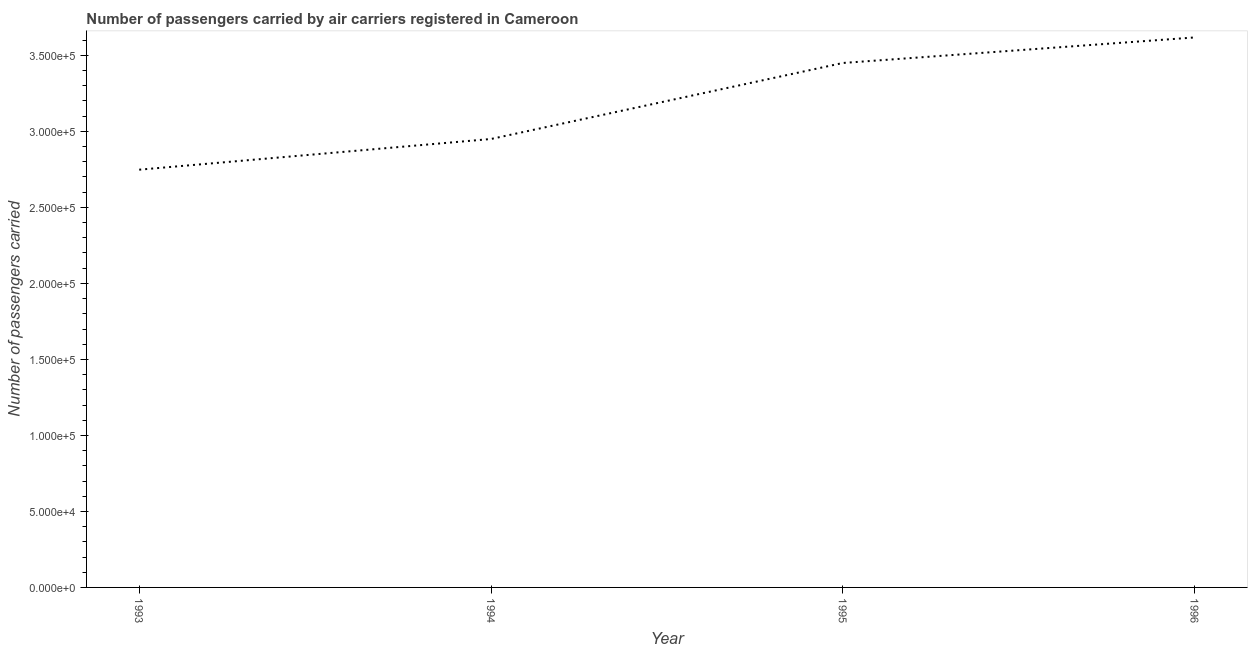What is the number of passengers carried in 1996?
Keep it short and to the point. 3.62e+05. Across all years, what is the maximum number of passengers carried?
Keep it short and to the point. 3.62e+05. Across all years, what is the minimum number of passengers carried?
Provide a succinct answer. 2.75e+05. In which year was the number of passengers carried minimum?
Your answer should be compact. 1993. What is the sum of the number of passengers carried?
Your answer should be compact. 1.28e+06. What is the difference between the number of passengers carried in 1993 and 1996?
Ensure brevity in your answer.  -8.70e+04. What is the average number of passengers carried per year?
Make the answer very short. 3.19e+05. In how many years, is the number of passengers carried greater than 250000 ?
Offer a terse response. 4. What is the ratio of the number of passengers carried in 1993 to that in 1996?
Your response must be concise. 0.76. Is the number of passengers carried in 1995 less than that in 1996?
Provide a short and direct response. Yes. What is the difference between the highest and the second highest number of passengers carried?
Provide a short and direct response. 1.68e+04. Is the sum of the number of passengers carried in 1993 and 1994 greater than the maximum number of passengers carried across all years?
Offer a very short reply. Yes. What is the difference between the highest and the lowest number of passengers carried?
Provide a succinct answer. 8.70e+04. In how many years, is the number of passengers carried greater than the average number of passengers carried taken over all years?
Give a very brief answer. 2. Does the number of passengers carried monotonically increase over the years?
Your answer should be very brief. Yes. What is the difference between two consecutive major ticks on the Y-axis?
Your answer should be very brief. 5.00e+04. Are the values on the major ticks of Y-axis written in scientific E-notation?
Provide a succinct answer. Yes. Does the graph contain any zero values?
Make the answer very short. No. What is the title of the graph?
Make the answer very short. Number of passengers carried by air carriers registered in Cameroon. What is the label or title of the X-axis?
Ensure brevity in your answer.  Year. What is the label or title of the Y-axis?
Make the answer very short. Number of passengers carried. What is the Number of passengers carried of 1993?
Provide a short and direct response. 2.75e+05. What is the Number of passengers carried of 1994?
Your answer should be very brief. 2.95e+05. What is the Number of passengers carried of 1995?
Your response must be concise. 3.45e+05. What is the Number of passengers carried in 1996?
Provide a short and direct response. 3.62e+05. What is the difference between the Number of passengers carried in 1993 and 1994?
Ensure brevity in your answer.  -2.02e+04. What is the difference between the Number of passengers carried in 1993 and 1995?
Provide a succinct answer. -7.02e+04. What is the difference between the Number of passengers carried in 1993 and 1996?
Offer a terse response. -8.70e+04. What is the difference between the Number of passengers carried in 1994 and 1995?
Provide a succinct answer. -5.00e+04. What is the difference between the Number of passengers carried in 1994 and 1996?
Make the answer very short. -6.68e+04. What is the difference between the Number of passengers carried in 1995 and 1996?
Your answer should be very brief. -1.68e+04. What is the ratio of the Number of passengers carried in 1993 to that in 1994?
Your answer should be very brief. 0.93. What is the ratio of the Number of passengers carried in 1993 to that in 1995?
Offer a terse response. 0.8. What is the ratio of the Number of passengers carried in 1993 to that in 1996?
Provide a short and direct response. 0.76. What is the ratio of the Number of passengers carried in 1994 to that in 1995?
Provide a short and direct response. 0.85. What is the ratio of the Number of passengers carried in 1994 to that in 1996?
Your answer should be compact. 0.81. What is the ratio of the Number of passengers carried in 1995 to that in 1996?
Keep it short and to the point. 0.95. 